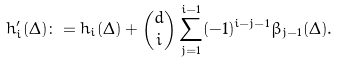<formula> <loc_0><loc_0><loc_500><loc_500>h ^ { \prime } _ { i } ( \Delta ) \colon = h _ { i } ( \Delta ) + { d \choose i } \sum _ { j = 1 } ^ { i - 1 } ( - 1 ) ^ { i - j - 1 } \beta _ { j - 1 } ( \Delta ) .</formula> 